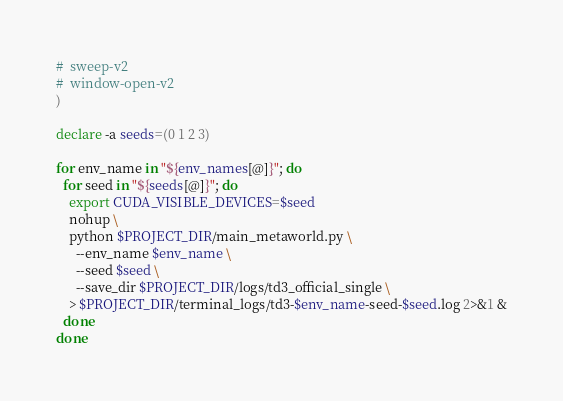Convert code to text. <code><loc_0><loc_0><loc_500><loc_500><_Bash_>#  sweep-v2
#  window-open-v2
)

declare -a seeds=(0 1 2 3)

for env_name in "${env_names[@]}"; do
  for seed in "${seeds[@]}"; do
    export CUDA_VISIBLE_DEVICES=$seed
    nohup \
    python $PROJECT_DIR/main_metaworld.py \
      --env_name $env_name \
      --seed $seed \
      --save_dir $PROJECT_DIR/logs/td3_official_single \
    > $PROJECT_DIR/terminal_logs/td3-$env_name-seed-$seed.log 2>&1 &
  done
done
</code> 